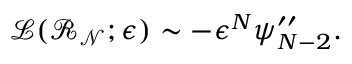Convert formula to latex. <formula><loc_0><loc_0><loc_500><loc_500>\mathcal { L } ( \mathcal { R _ { N } } ; \epsilon ) \sim - \epsilon ^ { N } \psi _ { N - 2 } ^ { \prime \prime } .</formula> 